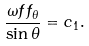<formula> <loc_0><loc_0><loc_500><loc_500>\frac { \omega f f _ { \theta } } { \sin \theta } = c _ { 1 } .</formula> 